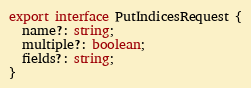Convert code to text. <code><loc_0><loc_0><loc_500><loc_500><_TypeScript_>export interface PutIndicesRequest {
  name?: string;
  multiple?: boolean;
  fields?: string;
}
</code> 